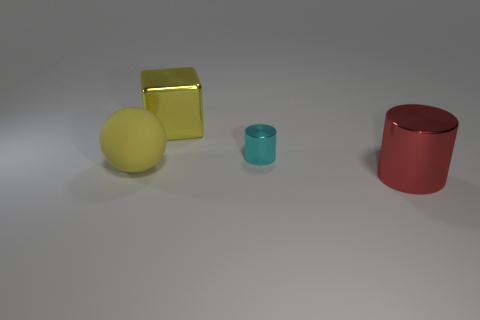Subtract all red balls. Subtract all green blocks. How many balls are left? 1 Add 4 tiny metal cylinders. How many objects exist? 8 Subtract all blocks. How many objects are left? 3 Subtract 0 brown spheres. How many objects are left? 4 Subtract all big shiny cylinders. Subtract all large yellow spheres. How many objects are left? 2 Add 4 big metal cubes. How many big metal cubes are left? 5 Add 4 brown matte objects. How many brown matte objects exist? 4 